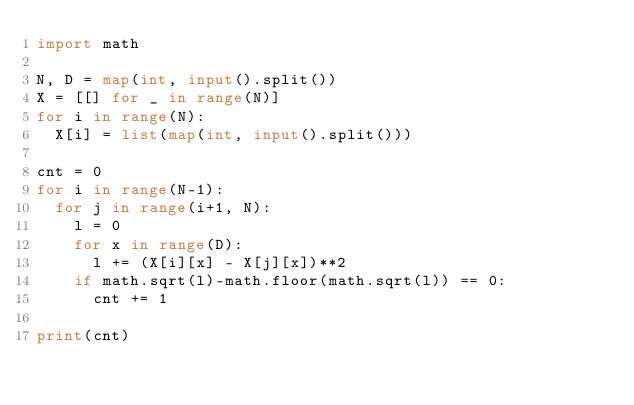Convert code to text. <code><loc_0><loc_0><loc_500><loc_500><_Python_>import math

N, D = map(int, input().split())
X = [[] for _ in range(N)]
for i in range(N):
	X[i] = list(map(int, input().split()))

cnt = 0
for i in range(N-1):
	for j in range(i+1, N):
		l = 0
		for x in range(D):
			l += (X[i][x] - X[j][x])**2
		if math.sqrt(l)-math.floor(math.sqrt(l)) == 0:
			cnt += 1

print(cnt)</code> 